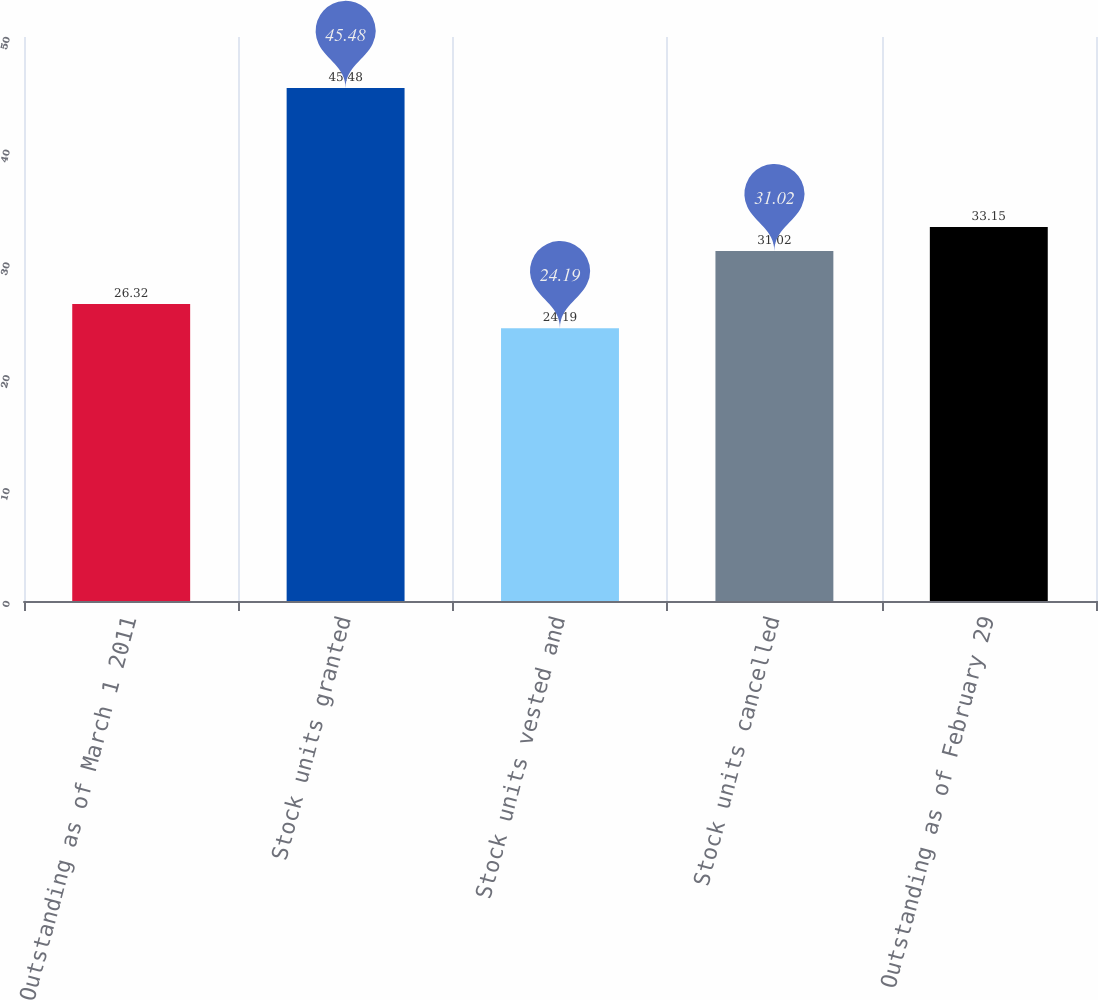Convert chart to OTSL. <chart><loc_0><loc_0><loc_500><loc_500><bar_chart><fcel>Outstanding as of March 1 2011<fcel>Stock units granted<fcel>Stock units vested and<fcel>Stock units cancelled<fcel>Outstanding as of February 29<nl><fcel>26.32<fcel>45.48<fcel>24.19<fcel>31.02<fcel>33.15<nl></chart> 